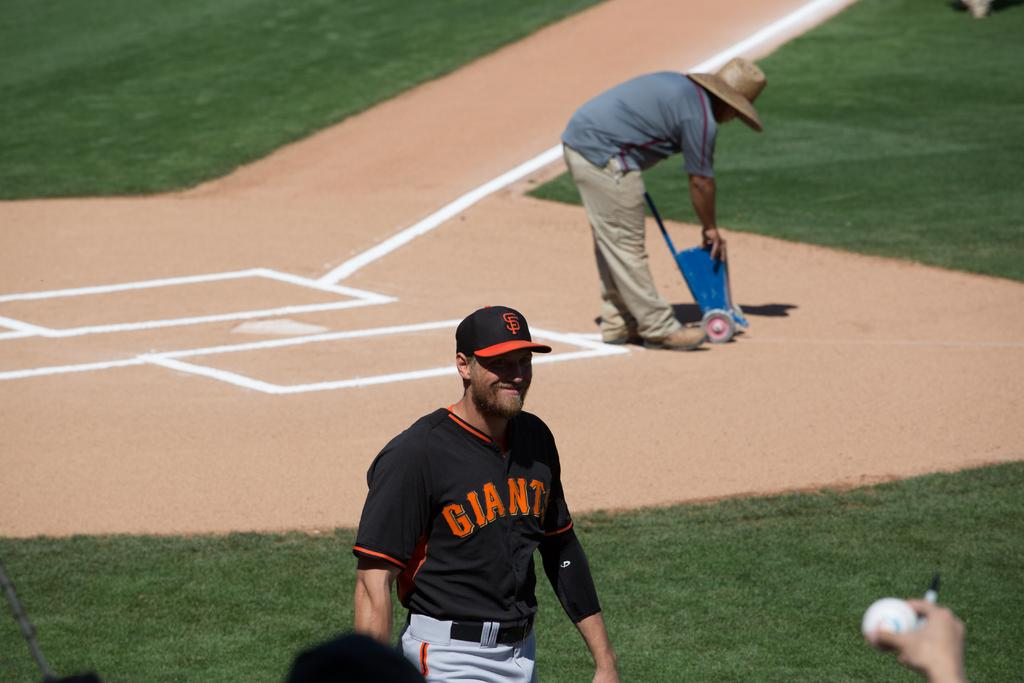<image>
Relay a brief, clear account of the picture shown. A giants baseball player walks off the field with a fan holding up a ball for him to sign. 